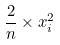Convert formula to latex. <formula><loc_0><loc_0><loc_500><loc_500>\frac { 2 } { n } \times x _ { i } ^ { 2 }</formula> 